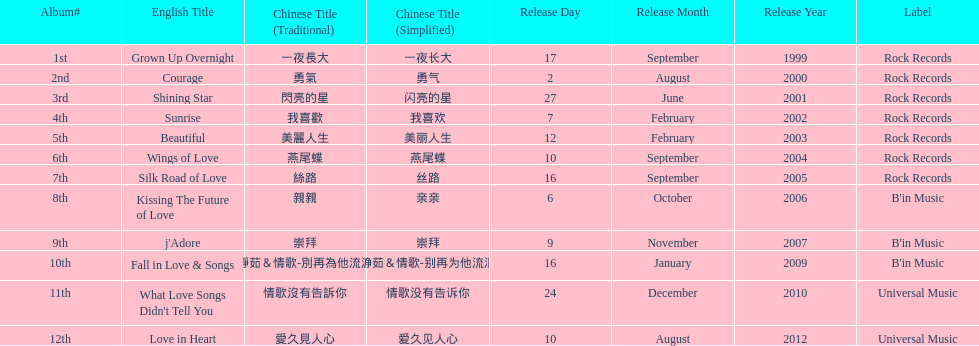Which song is listed first in the table? Grown Up Overnight. 